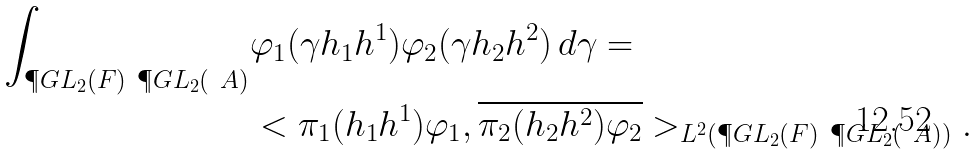<formula> <loc_0><loc_0><loc_500><loc_500>\int _ { \P G L _ { 2 } ( F ) \ \P G L _ { 2 } ( \ A ) } & \varphi _ { 1 } ( \gamma h _ { 1 } h ^ { 1 } ) \varphi _ { 2 } ( \gamma h _ { 2 } h ^ { 2 } ) \, d \gamma = \\ & < \pi _ { 1 } ( h _ { 1 } h ^ { 1 } ) \varphi _ { 1 } , \overline { \pi _ { 2 } ( h _ { 2 } h ^ { 2 } ) \varphi _ { 2 } } > _ { L ^ { 2 } ( \P G L _ { 2 } ( F ) \ \P G L _ { 2 } ( \ A ) ) } .</formula> 